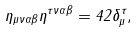Convert formula to latex. <formula><loc_0><loc_0><loc_500><loc_500>\eta _ { \mu \nu \alpha \beta } \eta ^ { \tau \nu \alpha \beta } = 4 2 \delta _ { \mu } ^ { \tau } ,</formula> 